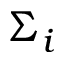Convert formula to latex. <formula><loc_0><loc_0><loc_500><loc_500>\Sigma _ { i }</formula> 